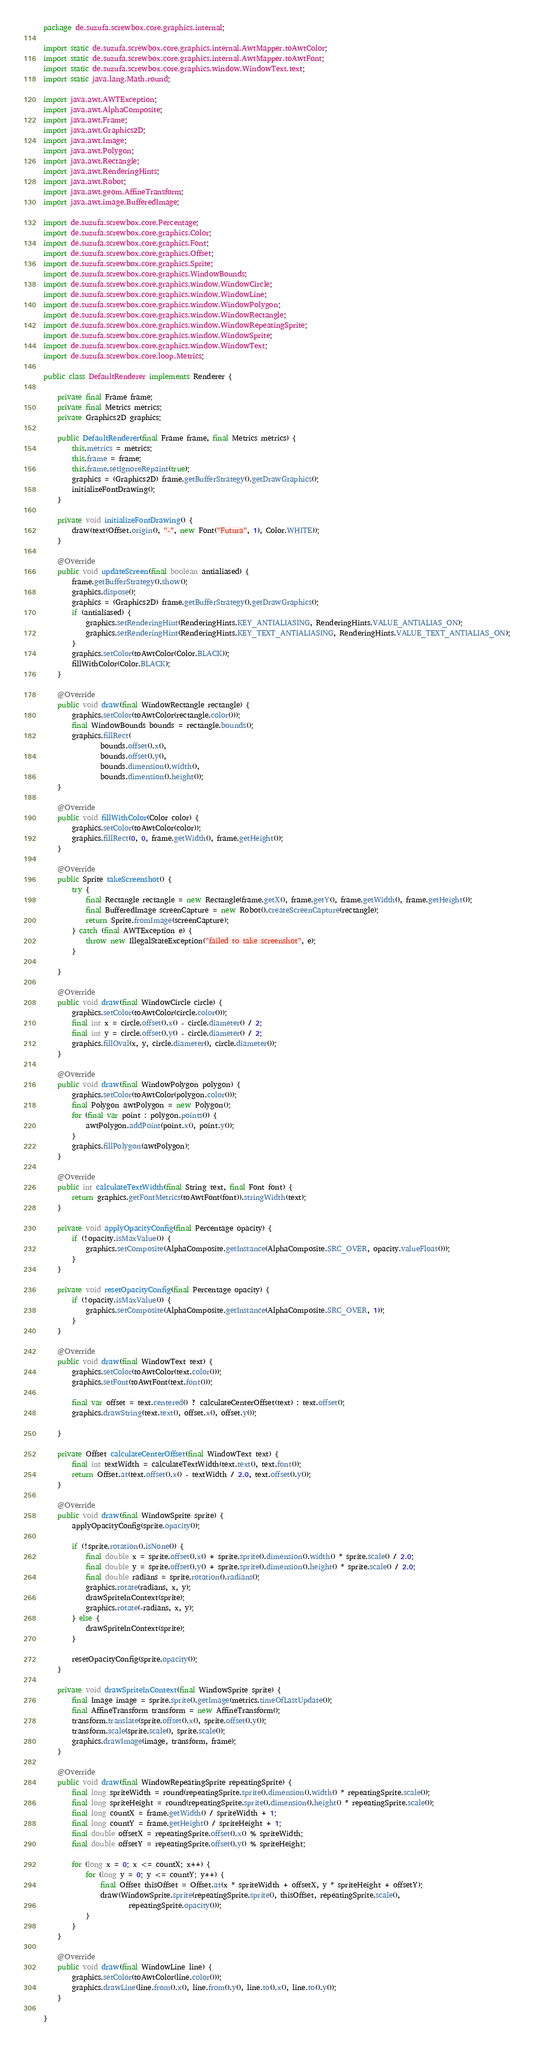<code> <loc_0><loc_0><loc_500><loc_500><_Java_>package de.suzufa.screwbox.core.graphics.internal;

import static de.suzufa.screwbox.core.graphics.internal.AwtMapper.toAwtColor;
import static de.suzufa.screwbox.core.graphics.internal.AwtMapper.toAwtFont;
import static de.suzufa.screwbox.core.graphics.window.WindowText.text;
import static java.lang.Math.round;

import java.awt.AWTException;
import java.awt.AlphaComposite;
import java.awt.Frame;
import java.awt.Graphics2D;
import java.awt.Image;
import java.awt.Polygon;
import java.awt.Rectangle;
import java.awt.RenderingHints;
import java.awt.Robot;
import java.awt.geom.AffineTransform;
import java.awt.image.BufferedImage;

import de.suzufa.screwbox.core.Percentage;
import de.suzufa.screwbox.core.graphics.Color;
import de.suzufa.screwbox.core.graphics.Font;
import de.suzufa.screwbox.core.graphics.Offset;
import de.suzufa.screwbox.core.graphics.Sprite;
import de.suzufa.screwbox.core.graphics.WindowBounds;
import de.suzufa.screwbox.core.graphics.window.WindowCircle;
import de.suzufa.screwbox.core.graphics.window.WindowLine;
import de.suzufa.screwbox.core.graphics.window.WindowPolygon;
import de.suzufa.screwbox.core.graphics.window.WindowRectangle;
import de.suzufa.screwbox.core.graphics.window.WindowRepeatingSprite;
import de.suzufa.screwbox.core.graphics.window.WindowSprite;
import de.suzufa.screwbox.core.graphics.window.WindowText;
import de.suzufa.screwbox.core.loop.Metrics;

public class DefaultRenderer implements Renderer {

    private final Frame frame;
    private final Metrics metrics;
    private Graphics2D graphics;

    public DefaultRenderer(final Frame frame, final Metrics metrics) {
        this.metrics = metrics;
        this.frame = frame;
        this.frame.setIgnoreRepaint(true);
        graphics = (Graphics2D) frame.getBufferStrategy().getDrawGraphics();
        initializeFontDrawing();
    }

    private void initializeFontDrawing() {
        draw(text(Offset.origin(), "-", new Font("Futura", 1), Color.WHITE));
    }

    @Override
    public void updateScreen(final boolean antialiased) {
        frame.getBufferStrategy().show();
        graphics.dispose();
        graphics = (Graphics2D) frame.getBufferStrategy().getDrawGraphics();
        if (antialiased) {
            graphics.setRenderingHint(RenderingHints.KEY_ANTIALIASING, RenderingHints.VALUE_ANTIALIAS_ON);
            graphics.setRenderingHint(RenderingHints.KEY_TEXT_ANTIALIASING, RenderingHints.VALUE_TEXT_ANTIALIAS_ON);
        }
        graphics.setColor(toAwtColor(Color.BLACK));
        fillWithColor(Color.BLACK);
    }

    @Override
    public void draw(final WindowRectangle rectangle) {
        graphics.setColor(toAwtColor(rectangle.color()));
        final WindowBounds bounds = rectangle.bounds();
        graphics.fillRect(
                bounds.offset().x(),
                bounds.offset().y(),
                bounds.dimension().width(),
                bounds.dimension().height());
    }

    @Override
    public void fillWithColor(Color color) {
        graphics.setColor(toAwtColor(color));
        graphics.fillRect(0, 0, frame.getWidth(), frame.getHeight());
    }

    @Override
    public Sprite takeScreenshot() {
        try {
            final Rectangle rectangle = new Rectangle(frame.getX(), frame.getY(), frame.getWidth(), frame.getHeight());
            final BufferedImage screenCapture = new Robot().createScreenCapture(rectangle);
            return Sprite.fromImage(screenCapture);
        } catch (final AWTException e) {
            throw new IllegalStateException("failed to take screenshot", e);
        }

    }

    @Override
    public void draw(final WindowCircle circle) {
        graphics.setColor(toAwtColor(circle.color()));
        final int x = circle.offset().x() - circle.diameter() / 2;
        final int y = circle.offset().y() - circle.diameter() / 2;
        graphics.fillOval(x, y, circle.diameter(), circle.diameter());
    }

    @Override
    public void draw(final WindowPolygon polygon) {
        graphics.setColor(toAwtColor(polygon.color()));
        final Polygon awtPolygon = new Polygon();
        for (final var point : polygon.points()) {
            awtPolygon.addPoint(point.x(), point.y());
        }
        graphics.fillPolygon(awtPolygon);
    }

    @Override
    public int calculateTextWidth(final String text, final Font font) {
        return graphics.getFontMetrics(toAwtFont(font)).stringWidth(text);
    }

    private void applyOpacityConfig(final Percentage opacity) {
        if (!opacity.isMaxValue()) {
            graphics.setComposite(AlphaComposite.getInstance(AlphaComposite.SRC_OVER, opacity.valueFloat()));
        }
    }

    private void resetOpacityConfig(final Percentage opacity) {
        if (!opacity.isMaxValue()) {
            graphics.setComposite(AlphaComposite.getInstance(AlphaComposite.SRC_OVER, 1));
        }
    }

    @Override
    public void draw(final WindowText text) {
        graphics.setColor(toAwtColor(text.color()));
        graphics.setFont(toAwtFont(text.font()));

        final var offset = text.centered() ? calculateCenterOffset(text) : text.offset();
        graphics.drawString(text.text(), offset.x(), offset.y());

    }

    private Offset calculateCenterOffset(final WindowText text) {
        final int textWidth = calculateTextWidth(text.text(), text.font());
        return Offset.at(text.offset().x() - textWidth / 2.0, text.offset().y());
    }

    @Override
    public void draw(final WindowSprite sprite) {
        applyOpacityConfig(sprite.opacity());

        if (!sprite.rotation().isNone()) {
            final double x = sprite.offset().x() + sprite.sprite().dimension().width() * sprite.scale() / 2.0;
            final double y = sprite.offset().y() + sprite.sprite().dimension().height() * sprite.scale() / 2.0;
            final double radians = sprite.rotation().radians();
            graphics.rotate(radians, x, y);
            drawSpriteInContext(sprite);
            graphics.rotate(-radians, x, y);
        } else {
            drawSpriteInContext(sprite);
        }

        resetOpacityConfig(sprite.opacity());
    }

    private void drawSpriteInContext(final WindowSprite sprite) {
        final Image image = sprite.sprite().getImage(metrics.timeOfLastUpdate());
        final AffineTransform transform = new AffineTransform();
        transform.translate(sprite.offset().x(), sprite.offset().y());
        transform.scale(sprite.scale(), sprite.scale());
        graphics.drawImage(image, transform, frame);
    }

    @Override
    public void draw(final WindowRepeatingSprite repeatingSprite) {
        final long spriteWidth = round(repeatingSprite.sprite().dimension().width() * repeatingSprite.scale());
        final long spriteHeight = round(repeatingSprite.sprite().dimension().height() * repeatingSprite.scale());
        final long countX = frame.getWidth() / spriteWidth + 1;
        final long countY = frame.getHeight() / spriteHeight + 1;
        final double offsetX = repeatingSprite.offset().x() % spriteWidth;
        final double offsetY = repeatingSprite.offset().y() % spriteHeight;

        for (long x = 0; x <= countX; x++) {
            for (long y = 0; y <= countY; y++) {
                final Offset thisOffset = Offset.at(x * spriteWidth + offsetX, y * spriteHeight + offsetY);
                draw(WindowSprite.sprite(repeatingSprite.sprite(), thisOffset, repeatingSprite.scale(),
                        repeatingSprite.opacity()));
            }
        }
    }

    @Override
    public void draw(final WindowLine line) {
        graphics.setColor(toAwtColor(line.color()));
        graphics.drawLine(line.from().x(), line.from().y(), line.to().x(), line.to().y());
    }

}
</code> 